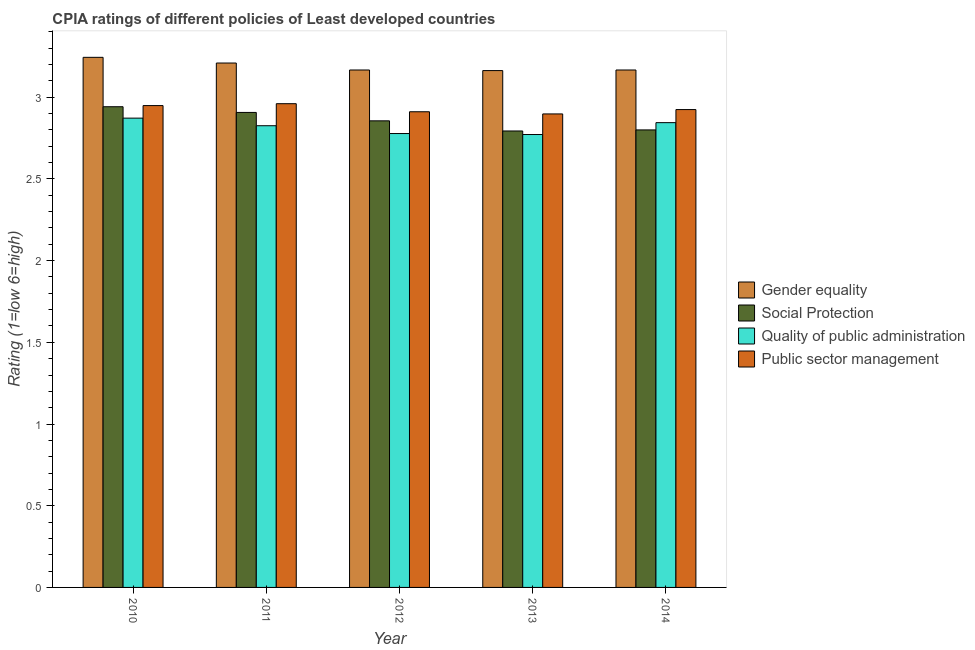Are the number of bars per tick equal to the number of legend labels?
Offer a very short reply. Yes. How many bars are there on the 4th tick from the left?
Keep it short and to the point. 4. How many bars are there on the 5th tick from the right?
Make the answer very short. 4. What is the label of the 3rd group of bars from the left?
Provide a succinct answer. 2012. What is the cpia rating of gender equality in 2011?
Offer a terse response. 3.21. Across all years, what is the maximum cpia rating of social protection?
Ensure brevity in your answer.  2.94. Across all years, what is the minimum cpia rating of public sector management?
Offer a very short reply. 2.9. In which year was the cpia rating of public sector management minimum?
Ensure brevity in your answer.  2013. What is the total cpia rating of public sector management in the graph?
Make the answer very short. 14.64. What is the difference between the cpia rating of gender equality in 2013 and that in 2014?
Offer a terse response. -0. What is the difference between the cpia rating of quality of public administration in 2014 and the cpia rating of social protection in 2013?
Provide a succinct answer. 0.07. What is the average cpia rating of social protection per year?
Offer a terse response. 2.86. In the year 2010, what is the difference between the cpia rating of public sector management and cpia rating of quality of public administration?
Your answer should be compact. 0. In how many years, is the cpia rating of public sector management greater than 0.9?
Offer a very short reply. 5. What is the ratio of the cpia rating of social protection in 2013 to that in 2014?
Offer a very short reply. 1. Is the cpia rating of social protection in 2011 less than that in 2014?
Provide a short and direct response. No. What is the difference between the highest and the second highest cpia rating of public sector management?
Give a very brief answer. 0.01. What is the difference between the highest and the lowest cpia rating of quality of public administration?
Your answer should be compact. 0.1. In how many years, is the cpia rating of social protection greater than the average cpia rating of social protection taken over all years?
Offer a terse response. 2. What does the 1st bar from the left in 2013 represents?
Give a very brief answer. Gender equality. What does the 1st bar from the right in 2011 represents?
Your answer should be compact. Public sector management. How many bars are there?
Provide a short and direct response. 20. Are the values on the major ticks of Y-axis written in scientific E-notation?
Your answer should be compact. No. How many legend labels are there?
Your answer should be compact. 4. How are the legend labels stacked?
Provide a short and direct response. Vertical. What is the title of the graph?
Your answer should be very brief. CPIA ratings of different policies of Least developed countries. Does "Primary" appear as one of the legend labels in the graph?
Keep it short and to the point. No. What is the label or title of the Y-axis?
Ensure brevity in your answer.  Rating (1=low 6=high). What is the Rating (1=low 6=high) in Gender equality in 2010?
Offer a terse response. 3.24. What is the Rating (1=low 6=high) in Social Protection in 2010?
Make the answer very short. 2.94. What is the Rating (1=low 6=high) in Quality of public administration in 2010?
Ensure brevity in your answer.  2.87. What is the Rating (1=low 6=high) in Public sector management in 2010?
Make the answer very short. 2.95. What is the Rating (1=low 6=high) in Gender equality in 2011?
Your answer should be very brief. 3.21. What is the Rating (1=low 6=high) of Social Protection in 2011?
Offer a terse response. 2.91. What is the Rating (1=low 6=high) in Quality of public administration in 2011?
Your answer should be very brief. 2.83. What is the Rating (1=low 6=high) in Public sector management in 2011?
Your answer should be very brief. 2.96. What is the Rating (1=low 6=high) of Gender equality in 2012?
Your response must be concise. 3.17. What is the Rating (1=low 6=high) in Social Protection in 2012?
Provide a succinct answer. 2.86. What is the Rating (1=low 6=high) of Quality of public administration in 2012?
Ensure brevity in your answer.  2.78. What is the Rating (1=low 6=high) in Public sector management in 2012?
Offer a very short reply. 2.91. What is the Rating (1=low 6=high) of Gender equality in 2013?
Keep it short and to the point. 3.16. What is the Rating (1=low 6=high) of Social Protection in 2013?
Give a very brief answer. 2.79. What is the Rating (1=low 6=high) of Quality of public administration in 2013?
Ensure brevity in your answer.  2.77. What is the Rating (1=low 6=high) of Public sector management in 2013?
Your answer should be compact. 2.9. What is the Rating (1=low 6=high) of Gender equality in 2014?
Ensure brevity in your answer.  3.17. What is the Rating (1=low 6=high) of Social Protection in 2014?
Your answer should be very brief. 2.8. What is the Rating (1=low 6=high) of Quality of public administration in 2014?
Give a very brief answer. 2.84. What is the Rating (1=low 6=high) in Public sector management in 2014?
Provide a succinct answer. 2.92. Across all years, what is the maximum Rating (1=low 6=high) in Gender equality?
Your answer should be very brief. 3.24. Across all years, what is the maximum Rating (1=low 6=high) in Social Protection?
Provide a short and direct response. 2.94. Across all years, what is the maximum Rating (1=low 6=high) of Quality of public administration?
Make the answer very short. 2.87. Across all years, what is the maximum Rating (1=low 6=high) in Public sector management?
Your answer should be very brief. 2.96. Across all years, what is the minimum Rating (1=low 6=high) in Gender equality?
Provide a short and direct response. 3.16. Across all years, what is the minimum Rating (1=low 6=high) in Social Protection?
Ensure brevity in your answer.  2.79. Across all years, what is the minimum Rating (1=low 6=high) in Quality of public administration?
Your response must be concise. 2.77. Across all years, what is the minimum Rating (1=low 6=high) of Public sector management?
Make the answer very short. 2.9. What is the total Rating (1=low 6=high) in Gender equality in the graph?
Provide a short and direct response. 15.95. What is the total Rating (1=low 6=high) of Social Protection in the graph?
Offer a terse response. 14.3. What is the total Rating (1=low 6=high) of Quality of public administration in the graph?
Make the answer very short. 14.09. What is the total Rating (1=low 6=high) of Public sector management in the graph?
Your response must be concise. 14.64. What is the difference between the Rating (1=low 6=high) of Gender equality in 2010 and that in 2011?
Offer a very short reply. 0.03. What is the difference between the Rating (1=low 6=high) of Social Protection in 2010 and that in 2011?
Provide a succinct answer. 0.03. What is the difference between the Rating (1=low 6=high) in Quality of public administration in 2010 and that in 2011?
Make the answer very short. 0.05. What is the difference between the Rating (1=low 6=high) in Public sector management in 2010 and that in 2011?
Provide a short and direct response. -0.01. What is the difference between the Rating (1=low 6=high) in Gender equality in 2010 and that in 2012?
Your answer should be very brief. 0.08. What is the difference between the Rating (1=low 6=high) in Social Protection in 2010 and that in 2012?
Give a very brief answer. 0.09. What is the difference between the Rating (1=low 6=high) of Quality of public administration in 2010 and that in 2012?
Your response must be concise. 0.09. What is the difference between the Rating (1=low 6=high) of Public sector management in 2010 and that in 2012?
Make the answer very short. 0.04. What is the difference between the Rating (1=low 6=high) in Gender equality in 2010 and that in 2013?
Give a very brief answer. 0.08. What is the difference between the Rating (1=low 6=high) in Social Protection in 2010 and that in 2013?
Give a very brief answer. 0.15. What is the difference between the Rating (1=low 6=high) of Quality of public administration in 2010 and that in 2013?
Keep it short and to the point. 0.1. What is the difference between the Rating (1=low 6=high) in Public sector management in 2010 and that in 2013?
Provide a short and direct response. 0.05. What is the difference between the Rating (1=low 6=high) of Gender equality in 2010 and that in 2014?
Your answer should be very brief. 0.08. What is the difference between the Rating (1=low 6=high) of Social Protection in 2010 and that in 2014?
Offer a very short reply. 0.14. What is the difference between the Rating (1=low 6=high) in Quality of public administration in 2010 and that in 2014?
Give a very brief answer. 0.03. What is the difference between the Rating (1=low 6=high) in Public sector management in 2010 and that in 2014?
Your answer should be compact. 0.02. What is the difference between the Rating (1=low 6=high) of Gender equality in 2011 and that in 2012?
Ensure brevity in your answer.  0.04. What is the difference between the Rating (1=low 6=high) of Social Protection in 2011 and that in 2012?
Ensure brevity in your answer.  0.05. What is the difference between the Rating (1=low 6=high) in Quality of public administration in 2011 and that in 2012?
Your answer should be compact. 0.05. What is the difference between the Rating (1=low 6=high) in Public sector management in 2011 and that in 2012?
Your answer should be very brief. 0.05. What is the difference between the Rating (1=low 6=high) of Gender equality in 2011 and that in 2013?
Make the answer very short. 0.05. What is the difference between the Rating (1=low 6=high) of Social Protection in 2011 and that in 2013?
Your answer should be compact. 0.11. What is the difference between the Rating (1=low 6=high) of Quality of public administration in 2011 and that in 2013?
Provide a short and direct response. 0.05. What is the difference between the Rating (1=low 6=high) of Public sector management in 2011 and that in 2013?
Your answer should be compact. 0.06. What is the difference between the Rating (1=low 6=high) in Gender equality in 2011 and that in 2014?
Your answer should be very brief. 0.04. What is the difference between the Rating (1=low 6=high) in Social Protection in 2011 and that in 2014?
Offer a terse response. 0.11. What is the difference between the Rating (1=low 6=high) in Quality of public administration in 2011 and that in 2014?
Your answer should be very brief. -0.02. What is the difference between the Rating (1=low 6=high) in Public sector management in 2011 and that in 2014?
Make the answer very short. 0.04. What is the difference between the Rating (1=low 6=high) in Gender equality in 2012 and that in 2013?
Your answer should be very brief. 0. What is the difference between the Rating (1=low 6=high) in Social Protection in 2012 and that in 2013?
Keep it short and to the point. 0.06. What is the difference between the Rating (1=low 6=high) in Quality of public administration in 2012 and that in 2013?
Provide a short and direct response. 0.01. What is the difference between the Rating (1=low 6=high) in Public sector management in 2012 and that in 2013?
Give a very brief answer. 0.01. What is the difference between the Rating (1=low 6=high) of Social Protection in 2012 and that in 2014?
Provide a succinct answer. 0.06. What is the difference between the Rating (1=low 6=high) of Quality of public administration in 2012 and that in 2014?
Offer a terse response. -0.07. What is the difference between the Rating (1=low 6=high) of Public sector management in 2012 and that in 2014?
Ensure brevity in your answer.  -0.01. What is the difference between the Rating (1=low 6=high) of Gender equality in 2013 and that in 2014?
Your answer should be compact. -0. What is the difference between the Rating (1=low 6=high) in Social Protection in 2013 and that in 2014?
Your answer should be very brief. -0.01. What is the difference between the Rating (1=low 6=high) of Quality of public administration in 2013 and that in 2014?
Your answer should be compact. -0.07. What is the difference between the Rating (1=low 6=high) of Public sector management in 2013 and that in 2014?
Your answer should be very brief. -0.03. What is the difference between the Rating (1=low 6=high) in Gender equality in 2010 and the Rating (1=low 6=high) in Social Protection in 2011?
Provide a succinct answer. 0.34. What is the difference between the Rating (1=low 6=high) in Gender equality in 2010 and the Rating (1=low 6=high) in Quality of public administration in 2011?
Give a very brief answer. 0.42. What is the difference between the Rating (1=low 6=high) of Gender equality in 2010 and the Rating (1=low 6=high) of Public sector management in 2011?
Offer a very short reply. 0.28. What is the difference between the Rating (1=low 6=high) in Social Protection in 2010 and the Rating (1=low 6=high) in Quality of public administration in 2011?
Your answer should be compact. 0.12. What is the difference between the Rating (1=low 6=high) of Social Protection in 2010 and the Rating (1=low 6=high) of Public sector management in 2011?
Keep it short and to the point. -0.02. What is the difference between the Rating (1=low 6=high) in Quality of public administration in 2010 and the Rating (1=low 6=high) in Public sector management in 2011?
Give a very brief answer. -0.09. What is the difference between the Rating (1=low 6=high) in Gender equality in 2010 and the Rating (1=low 6=high) in Social Protection in 2012?
Make the answer very short. 0.39. What is the difference between the Rating (1=low 6=high) of Gender equality in 2010 and the Rating (1=low 6=high) of Quality of public administration in 2012?
Provide a succinct answer. 0.47. What is the difference between the Rating (1=low 6=high) of Gender equality in 2010 and the Rating (1=low 6=high) of Public sector management in 2012?
Your answer should be very brief. 0.33. What is the difference between the Rating (1=low 6=high) of Social Protection in 2010 and the Rating (1=low 6=high) of Quality of public administration in 2012?
Your answer should be compact. 0.16. What is the difference between the Rating (1=low 6=high) in Social Protection in 2010 and the Rating (1=low 6=high) in Public sector management in 2012?
Ensure brevity in your answer.  0.03. What is the difference between the Rating (1=low 6=high) of Quality of public administration in 2010 and the Rating (1=low 6=high) of Public sector management in 2012?
Offer a very short reply. -0.04. What is the difference between the Rating (1=low 6=high) in Gender equality in 2010 and the Rating (1=low 6=high) in Social Protection in 2013?
Your answer should be very brief. 0.45. What is the difference between the Rating (1=low 6=high) in Gender equality in 2010 and the Rating (1=low 6=high) in Quality of public administration in 2013?
Provide a succinct answer. 0.47. What is the difference between the Rating (1=low 6=high) in Gender equality in 2010 and the Rating (1=low 6=high) in Public sector management in 2013?
Your answer should be compact. 0.35. What is the difference between the Rating (1=low 6=high) in Social Protection in 2010 and the Rating (1=low 6=high) in Quality of public administration in 2013?
Your answer should be compact. 0.17. What is the difference between the Rating (1=low 6=high) of Social Protection in 2010 and the Rating (1=low 6=high) of Public sector management in 2013?
Your answer should be compact. 0.04. What is the difference between the Rating (1=low 6=high) of Quality of public administration in 2010 and the Rating (1=low 6=high) of Public sector management in 2013?
Provide a short and direct response. -0.03. What is the difference between the Rating (1=low 6=high) of Gender equality in 2010 and the Rating (1=low 6=high) of Social Protection in 2014?
Keep it short and to the point. 0.44. What is the difference between the Rating (1=low 6=high) of Gender equality in 2010 and the Rating (1=low 6=high) of Quality of public administration in 2014?
Make the answer very short. 0.4. What is the difference between the Rating (1=low 6=high) of Gender equality in 2010 and the Rating (1=low 6=high) of Public sector management in 2014?
Make the answer very short. 0.32. What is the difference between the Rating (1=low 6=high) of Social Protection in 2010 and the Rating (1=low 6=high) of Quality of public administration in 2014?
Offer a very short reply. 0.1. What is the difference between the Rating (1=low 6=high) of Social Protection in 2010 and the Rating (1=low 6=high) of Public sector management in 2014?
Your answer should be compact. 0.02. What is the difference between the Rating (1=low 6=high) of Quality of public administration in 2010 and the Rating (1=low 6=high) of Public sector management in 2014?
Offer a terse response. -0.05. What is the difference between the Rating (1=low 6=high) of Gender equality in 2011 and the Rating (1=low 6=high) of Social Protection in 2012?
Keep it short and to the point. 0.35. What is the difference between the Rating (1=low 6=high) in Gender equality in 2011 and the Rating (1=low 6=high) in Quality of public administration in 2012?
Offer a very short reply. 0.43. What is the difference between the Rating (1=low 6=high) in Gender equality in 2011 and the Rating (1=low 6=high) in Public sector management in 2012?
Your answer should be compact. 0.3. What is the difference between the Rating (1=low 6=high) of Social Protection in 2011 and the Rating (1=low 6=high) of Quality of public administration in 2012?
Your answer should be compact. 0.13. What is the difference between the Rating (1=low 6=high) of Social Protection in 2011 and the Rating (1=low 6=high) of Public sector management in 2012?
Provide a succinct answer. -0. What is the difference between the Rating (1=low 6=high) of Quality of public administration in 2011 and the Rating (1=low 6=high) of Public sector management in 2012?
Provide a short and direct response. -0.09. What is the difference between the Rating (1=low 6=high) in Gender equality in 2011 and the Rating (1=low 6=high) in Social Protection in 2013?
Give a very brief answer. 0.42. What is the difference between the Rating (1=low 6=high) of Gender equality in 2011 and the Rating (1=low 6=high) of Quality of public administration in 2013?
Provide a succinct answer. 0.44. What is the difference between the Rating (1=low 6=high) in Gender equality in 2011 and the Rating (1=low 6=high) in Public sector management in 2013?
Your answer should be very brief. 0.31. What is the difference between the Rating (1=low 6=high) of Social Protection in 2011 and the Rating (1=low 6=high) of Quality of public administration in 2013?
Offer a very short reply. 0.14. What is the difference between the Rating (1=low 6=high) of Social Protection in 2011 and the Rating (1=low 6=high) of Public sector management in 2013?
Offer a terse response. 0.01. What is the difference between the Rating (1=low 6=high) of Quality of public administration in 2011 and the Rating (1=low 6=high) of Public sector management in 2013?
Make the answer very short. -0.07. What is the difference between the Rating (1=low 6=high) in Gender equality in 2011 and the Rating (1=low 6=high) in Social Protection in 2014?
Give a very brief answer. 0.41. What is the difference between the Rating (1=low 6=high) of Gender equality in 2011 and the Rating (1=low 6=high) of Quality of public administration in 2014?
Offer a very short reply. 0.36. What is the difference between the Rating (1=low 6=high) in Gender equality in 2011 and the Rating (1=low 6=high) in Public sector management in 2014?
Ensure brevity in your answer.  0.28. What is the difference between the Rating (1=low 6=high) of Social Protection in 2011 and the Rating (1=low 6=high) of Quality of public administration in 2014?
Provide a succinct answer. 0.06. What is the difference between the Rating (1=low 6=high) of Social Protection in 2011 and the Rating (1=low 6=high) of Public sector management in 2014?
Your response must be concise. -0.02. What is the difference between the Rating (1=low 6=high) of Quality of public administration in 2011 and the Rating (1=low 6=high) of Public sector management in 2014?
Provide a short and direct response. -0.1. What is the difference between the Rating (1=low 6=high) in Gender equality in 2012 and the Rating (1=low 6=high) in Social Protection in 2013?
Make the answer very short. 0.37. What is the difference between the Rating (1=low 6=high) of Gender equality in 2012 and the Rating (1=low 6=high) of Quality of public administration in 2013?
Keep it short and to the point. 0.39. What is the difference between the Rating (1=low 6=high) in Gender equality in 2012 and the Rating (1=low 6=high) in Public sector management in 2013?
Your answer should be very brief. 0.27. What is the difference between the Rating (1=low 6=high) in Social Protection in 2012 and the Rating (1=low 6=high) in Quality of public administration in 2013?
Give a very brief answer. 0.08. What is the difference between the Rating (1=low 6=high) of Social Protection in 2012 and the Rating (1=low 6=high) of Public sector management in 2013?
Ensure brevity in your answer.  -0.04. What is the difference between the Rating (1=low 6=high) of Quality of public administration in 2012 and the Rating (1=low 6=high) of Public sector management in 2013?
Offer a very short reply. -0.12. What is the difference between the Rating (1=low 6=high) in Gender equality in 2012 and the Rating (1=low 6=high) in Social Protection in 2014?
Your answer should be compact. 0.37. What is the difference between the Rating (1=low 6=high) in Gender equality in 2012 and the Rating (1=low 6=high) in Quality of public administration in 2014?
Offer a very short reply. 0.32. What is the difference between the Rating (1=low 6=high) in Gender equality in 2012 and the Rating (1=low 6=high) in Public sector management in 2014?
Make the answer very short. 0.24. What is the difference between the Rating (1=low 6=high) of Social Protection in 2012 and the Rating (1=low 6=high) of Quality of public administration in 2014?
Ensure brevity in your answer.  0.01. What is the difference between the Rating (1=low 6=high) in Social Protection in 2012 and the Rating (1=low 6=high) in Public sector management in 2014?
Your response must be concise. -0.07. What is the difference between the Rating (1=low 6=high) of Quality of public administration in 2012 and the Rating (1=low 6=high) of Public sector management in 2014?
Provide a short and direct response. -0.15. What is the difference between the Rating (1=low 6=high) in Gender equality in 2013 and the Rating (1=low 6=high) in Social Protection in 2014?
Ensure brevity in your answer.  0.36. What is the difference between the Rating (1=low 6=high) of Gender equality in 2013 and the Rating (1=low 6=high) of Quality of public administration in 2014?
Give a very brief answer. 0.32. What is the difference between the Rating (1=low 6=high) of Gender equality in 2013 and the Rating (1=low 6=high) of Public sector management in 2014?
Your answer should be compact. 0.24. What is the difference between the Rating (1=low 6=high) of Social Protection in 2013 and the Rating (1=low 6=high) of Quality of public administration in 2014?
Offer a terse response. -0.05. What is the difference between the Rating (1=low 6=high) in Social Protection in 2013 and the Rating (1=low 6=high) in Public sector management in 2014?
Your answer should be very brief. -0.13. What is the difference between the Rating (1=low 6=high) in Quality of public administration in 2013 and the Rating (1=low 6=high) in Public sector management in 2014?
Give a very brief answer. -0.15. What is the average Rating (1=low 6=high) of Gender equality per year?
Keep it short and to the point. 3.19. What is the average Rating (1=low 6=high) of Social Protection per year?
Keep it short and to the point. 2.86. What is the average Rating (1=low 6=high) of Quality of public administration per year?
Keep it short and to the point. 2.82. What is the average Rating (1=low 6=high) of Public sector management per year?
Your answer should be very brief. 2.93. In the year 2010, what is the difference between the Rating (1=low 6=high) of Gender equality and Rating (1=low 6=high) of Social Protection?
Provide a succinct answer. 0.3. In the year 2010, what is the difference between the Rating (1=low 6=high) of Gender equality and Rating (1=low 6=high) of Quality of public administration?
Your answer should be compact. 0.37. In the year 2010, what is the difference between the Rating (1=low 6=high) in Gender equality and Rating (1=low 6=high) in Public sector management?
Your response must be concise. 0.3. In the year 2010, what is the difference between the Rating (1=low 6=high) of Social Protection and Rating (1=low 6=high) of Quality of public administration?
Provide a succinct answer. 0.07. In the year 2010, what is the difference between the Rating (1=low 6=high) in Social Protection and Rating (1=low 6=high) in Public sector management?
Offer a terse response. -0.01. In the year 2010, what is the difference between the Rating (1=low 6=high) of Quality of public administration and Rating (1=low 6=high) of Public sector management?
Offer a very short reply. -0.08. In the year 2011, what is the difference between the Rating (1=low 6=high) in Gender equality and Rating (1=low 6=high) in Social Protection?
Ensure brevity in your answer.  0.3. In the year 2011, what is the difference between the Rating (1=low 6=high) in Gender equality and Rating (1=low 6=high) in Quality of public administration?
Your answer should be compact. 0.38. In the year 2011, what is the difference between the Rating (1=low 6=high) in Gender equality and Rating (1=low 6=high) in Public sector management?
Provide a short and direct response. 0.25. In the year 2011, what is the difference between the Rating (1=low 6=high) of Social Protection and Rating (1=low 6=high) of Quality of public administration?
Make the answer very short. 0.08. In the year 2011, what is the difference between the Rating (1=low 6=high) of Social Protection and Rating (1=low 6=high) of Public sector management?
Keep it short and to the point. -0.05. In the year 2011, what is the difference between the Rating (1=low 6=high) in Quality of public administration and Rating (1=low 6=high) in Public sector management?
Your answer should be compact. -0.13. In the year 2012, what is the difference between the Rating (1=low 6=high) of Gender equality and Rating (1=low 6=high) of Social Protection?
Provide a short and direct response. 0.31. In the year 2012, what is the difference between the Rating (1=low 6=high) of Gender equality and Rating (1=low 6=high) of Quality of public administration?
Your answer should be very brief. 0.39. In the year 2012, what is the difference between the Rating (1=low 6=high) of Gender equality and Rating (1=low 6=high) of Public sector management?
Your response must be concise. 0.26. In the year 2012, what is the difference between the Rating (1=low 6=high) of Social Protection and Rating (1=low 6=high) of Quality of public administration?
Give a very brief answer. 0.08. In the year 2012, what is the difference between the Rating (1=low 6=high) in Social Protection and Rating (1=low 6=high) in Public sector management?
Your answer should be very brief. -0.06. In the year 2012, what is the difference between the Rating (1=low 6=high) of Quality of public administration and Rating (1=low 6=high) of Public sector management?
Your response must be concise. -0.13. In the year 2013, what is the difference between the Rating (1=low 6=high) in Gender equality and Rating (1=low 6=high) in Social Protection?
Offer a very short reply. 0.37. In the year 2013, what is the difference between the Rating (1=low 6=high) in Gender equality and Rating (1=low 6=high) in Quality of public administration?
Make the answer very short. 0.39. In the year 2013, what is the difference between the Rating (1=low 6=high) in Gender equality and Rating (1=low 6=high) in Public sector management?
Your answer should be very brief. 0.27. In the year 2013, what is the difference between the Rating (1=low 6=high) in Social Protection and Rating (1=low 6=high) in Quality of public administration?
Offer a terse response. 0.02. In the year 2013, what is the difference between the Rating (1=low 6=high) of Social Protection and Rating (1=low 6=high) of Public sector management?
Keep it short and to the point. -0.1. In the year 2013, what is the difference between the Rating (1=low 6=high) of Quality of public administration and Rating (1=low 6=high) of Public sector management?
Offer a very short reply. -0.13. In the year 2014, what is the difference between the Rating (1=low 6=high) of Gender equality and Rating (1=low 6=high) of Social Protection?
Your answer should be very brief. 0.37. In the year 2014, what is the difference between the Rating (1=low 6=high) of Gender equality and Rating (1=low 6=high) of Quality of public administration?
Ensure brevity in your answer.  0.32. In the year 2014, what is the difference between the Rating (1=low 6=high) in Gender equality and Rating (1=low 6=high) in Public sector management?
Provide a short and direct response. 0.24. In the year 2014, what is the difference between the Rating (1=low 6=high) of Social Protection and Rating (1=low 6=high) of Quality of public administration?
Provide a succinct answer. -0.04. In the year 2014, what is the difference between the Rating (1=low 6=high) of Social Protection and Rating (1=low 6=high) of Public sector management?
Provide a short and direct response. -0.12. In the year 2014, what is the difference between the Rating (1=low 6=high) in Quality of public administration and Rating (1=low 6=high) in Public sector management?
Offer a very short reply. -0.08. What is the ratio of the Rating (1=low 6=high) in Gender equality in 2010 to that in 2011?
Provide a succinct answer. 1.01. What is the ratio of the Rating (1=low 6=high) of Social Protection in 2010 to that in 2011?
Your answer should be very brief. 1.01. What is the ratio of the Rating (1=low 6=high) of Quality of public administration in 2010 to that in 2011?
Your response must be concise. 1.02. What is the ratio of the Rating (1=low 6=high) of Gender equality in 2010 to that in 2012?
Offer a terse response. 1.02. What is the ratio of the Rating (1=low 6=high) of Social Protection in 2010 to that in 2012?
Offer a terse response. 1.03. What is the ratio of the Rating (1=low 6=high) in Quality of public administration in 2010 to that in 2012?
Provide a short and direct response. 1.03. What is the ratio of the Rating (1=low 6=high) of Public sector management in 2010 to that in 2012?
Your answer should be very brief. 1.01. What is the ratio of the Rating (1=low 6=high) in Gender equality in 2010 to that in 2013?
Offer a terse response. 1.03. What is the ratio of the Rating (1=low 6=high) in Social Protection in 2010 to that in 2013?
Your answer should be compact. 1.05. What is the ratio of the Rating (1=low 6=high) in Quality of public administration in 2010 to that in 2013?
Offer a terse response. 1.04. What is the ratio of the Rating (1=low 6=high) in Public sector management in 2010 to that in 2013?
Make the answer very short. 1.02. What is the ratio of the Rating (1=low 6=high) of Gender equality in 2010 to that in 2014?
Your answer should be compact. 1.02. What is the ratio of the Rating (1=low 6=high) in Social Protection in 2010 to that in 2014?
Provide a succinct answer. 1.05. What is the ratio of the Rating (1=low 6=high) in Quality of public administration in 2010 to that in 2014?
Provide a short and direct response. 1.01. What is the ratio of the Rating (1=low 6=high) of Public sector management in 2010 to that in 2014?
Offer a terse response. 1.01. What is the ratio of the Rating (1=low 6=high) in Gender equality in 2011 to that in 2012?
Ensure brevity in your answer.  1.01. What is the ratio of the Rating (1=low 6=high) of Social Protection in 2011 to that in 2012?
Give a very brief answer. 1.02. What is the ratio of the Rating (1=low 6=high) of Quality of public administration in 2011 to that in 2012?
Offer a very short reply. 1.02. What is the ratio of the Rating (1=low 6=high) of Gender equality in 2011 to that in 2013?
Your response must be concise. 1.01. What is the ratio of the Rating (1=low 6=high) of Social Protection in 2011 to that in 2013?
Ensure brevity in your answer.  1.04. What is the ratio of the Rating (1=low 6=high) in Quality of public administration in 2011 to that in 2013?
Your answer should be compact. 1.02. What is the ratio of the Rating (1=low 6=high) in Public sector management in 2011 to that in 2013?
Your response must be concise. 1.02. What is the ratio of the Rating (1=low 6=high) of Gender equality in 2011 to that in 2014?
Your response must be concise. 1.01. What is the ratio of the Rating (1=low 6=high) in Social Protection in 2011 to that in 2014?
Provide a succinct answer. 1.04. What is the ratio of the Rating (1=low 6=high) of Quality of public administration in 2011 to that in 2014?
Provide a short and direct response. 0.99. What is the ratio of the Rating (1=low 6=high) in Public sector management in 2011 to that in 2014?
Your response must be concise. 1.01. What is the ratio of the Rating (1=low 6=high) of Social Protection in 2012 to that in 2013?
Ensure brevity in your answer.  1.02. What is the ratio of the Rating (1=low 6=high) of Quality of public administration in 2012 to that in 2013?
Provide a succinct answer. 1. What is the ratio of the Rating (1=low 6=high) of Gender equality in 2012 to that in 2014?
Your answer should be compact. 1. What is the ratio of the Rating (1=low 6=high) in Social Protection in 2012 to that in 2014?
Offer a terse response. 1.02. What is the ratio of the Rating (1=low 6=high) in Quality of public administration in 2012 to that in 2014?
Offer a terse response. 0.98. What is the ratio of the Rating (1=low 6=high) of Public sector management in 2012 to that in 2014?
Ensure brevity in your answer.  1. What is the ratio of the Rating (1=low 6=high) of Quality of public administration in 2013 to that in 2014?
Your response must be concise. 0.97. What is the ratio of the Rating (1=low 6=high) of Public sector management in 2013 to that in 2014?
Your answer should be compact. 0.99. What is the difference between the highest and the second highest Rating (1=low 6=high) in Gender equality?
Ensure brevity in your answer.  0.03. What is the difference between the highest and the second highest Rating (1=low 6=high) in Social Protection?
Give a very brief answer. 0.03. What is the difference between the highest and the second highest Rating (1=low 6=high) of Quality of public administration?
Your answer should be very brief. 0.03. What is the difference between the highest and the second highest Rating (1=low 6=high) in Public sector management?
Give a very brief answer. 0.01. What is the difference between the highest and the lowest Rating (1=low 6=high) of Gender equality?
Ensure brevity in your answer.  0.08. What is the difference between the highest and the lowest Rating (1=low 6=high) of Social Protection?
Offer a terse response. 0.15. What is the difference between the highest and the lowest Rating (1=low 6=high) of Quality of public administration?
Make the answer very short. 0.1. What is the difference between the highest and the lowest Rating (1=low 6=high) of Public sector management?
Keep it short and to the point. 0.06. 